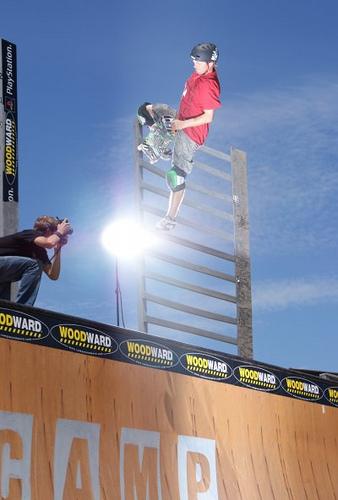What is the name of the apparatus the skater is using?
Be succinct. Skateboard. What color is the skaters shirt?
Quick response, please. Red. What is the camera man doing?
Quick response, please. Taking photo. 